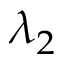<formula> <loc_0><loc_0><loc_500><loc_500>\lambda _ { 2 }</formula> 